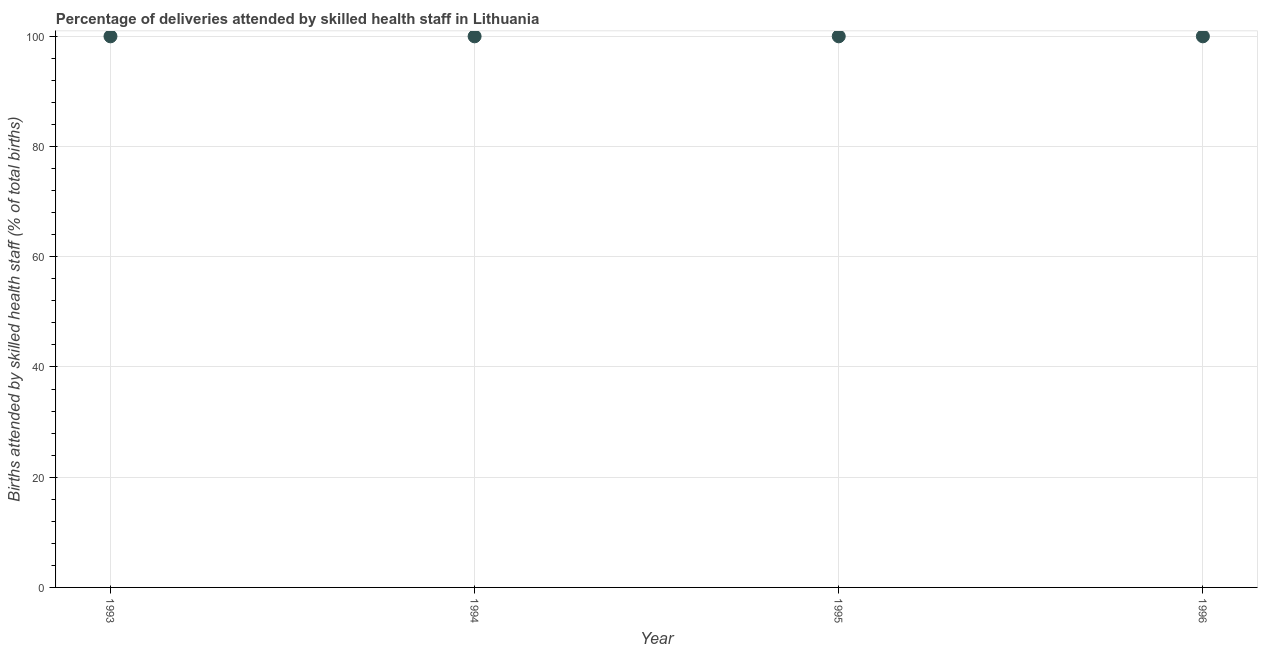What is the number of births attended by skilled health staff in 1993?
Your response must be concise. 100. Across all years, what is the maximum number of births attended by skilled health staff?
Make the answer very short. 100. Across all years, what is the minimum number of births attended by skilled health staff?
Provide a short and direct response. 100. In which year was the number of births attended by skilled health staff maximum?
Keep it short and to the point. 1993. What is the sum of the number of births attended by skilled health staff?
Offer a very short reply. 400. What is the median number of births attended by skilled health staff?
Offer a terse response. 100. In how many years, is the number of births attended by skilled health staff greater than 56 %?
Your answer should be compact. 4. Do a majority of the years between 1993 and 1995 (inclusive) have number of births attended by skilled health staff greater than 64 %?
Provide a succinct answer. Yes. What is the difference between the highest and the second highest number of births attended by skilled health staff?
Give a very brief answer. 0. What is the difference between the highest and the lowest number of births attended by skilled health staff?
Make the answer very short. 0. In how many years, is the number of births attended by skilled health staff greater than the average number of births attended by skilled health staff taken over all years?
Ensure brevity in your answer.  0. How many dotlines are there?
Offer a terse response. 1. What is the title of the graph?
Your answer should be very brief. Percentage of deliveries attended by skilled health staff in Lithuania. What is the label or title of the Y-axis?
Your answer should be compact. Births attended by skilled health staff (% of total births). What is the Births attended by skilled health staff (% of total births) in 1994?
Offer a terse response. 100. What is the Births attended by skilled health staff (% of total births) in 1995?
Offer a terse response. 100. What is the Births attended by skilled health staff (% of total births) in 1996?
Give a very brief answer. 100. What is the difference between the Births attended by skilled health staff (% of total births) in 1993 and 1996?
Give a very brief answer. 0. What is the difference between the Births attended by skilled health staff (% of total births) in 1994 and 1995?
Make the answer very short. 0. What is the difference between the Births attended by skilled health staff (% of total births) in 1994 and 1996?
Offer a terse response. 0. What is the ratio of the Births attended by skilled health staff (% of total births) in 1994 to that in 1996?
Make the answer very short. 1. 